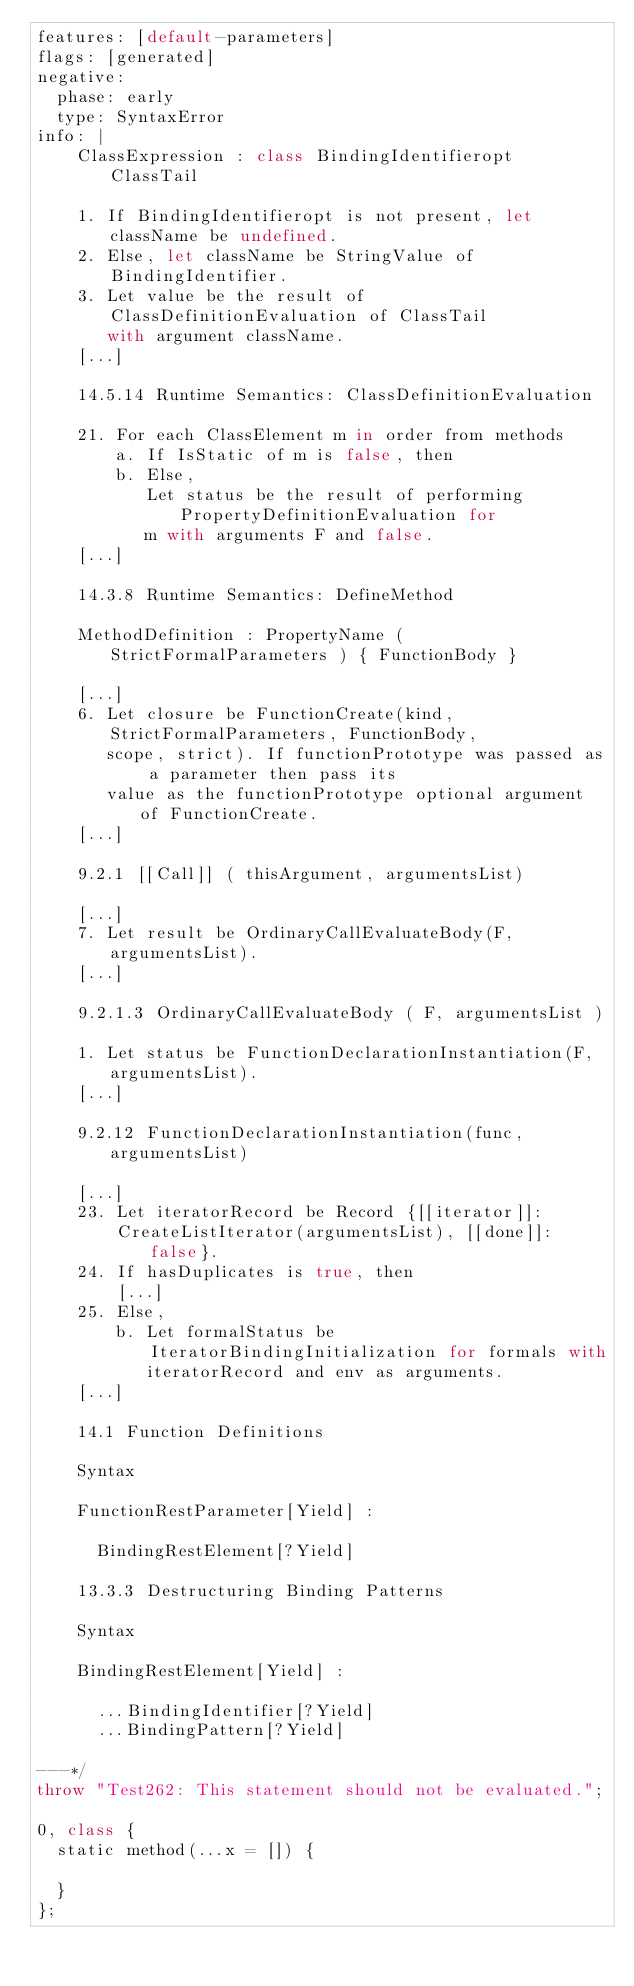Convert code to text. <code><loc_0><loc_0><loc_500><loc_500><_JavaScript_>features: [default-parameters]
flags: [generated]
negative:
  phase: early
  type: SyntaxError
info: |
    ClassExpression : class BindingIdentifieropt ClassTail

    1. If BindingIdentifieropt is not present, let className be undefined.
    2. Else, let className be StringValue of BindingIdentifier.
    3. Let value be the result of ClassDefinitionEvaluation of ClassTail
       with argument className.
    [...]

    14.5.14 Runtime Semantics: ClassDefinitionEvaluation

    21. For each ClassElement m in order from methods
        a. If IsStatic of m is false, then
        b. Else,
           Let status be the result of performing PropertyDefinitionEvaluation for
           m with arguments F and false.
    [...]

    14.3.8 Runtime Semantics: DefineMethod

    MethodDefinition : PropertyName ( StrictFormalParameters ) { FunctionBody }

    [...]
    6. Let closure be FunctionCreate(kind, StrictFormalParameters, FunctionBody,
       scope, strict). If functionPrototype was passed as a parameter then pass its
       value as the functionPrototype optional argument of FunctionCreate.
    [...]

    9.2.1 [[Call]] ( thisArgument, argumentsList)

    [...]
    7. Let result be OrdinaryCallEvaluateBody(F, argumentsList).
    [...]

    9.2.1.3 OrdinaryCallEvaluateBody ( F, argumentsList )

    1. Let status be FunctionDeclarationInstantiation(F, argumentsList).
    [...]

    9.2.12 FunctionDeclarationInstantiation(func, argumentsList)

    [...]
    23. Let iteratorRecord be Record {[[iterator]]:
        CreateListIterator(argumentsList), [[done]]: false}.
    24. If hasDuplicates is true, then
        [...]
    25. Else,
        b. Let formalStatus be IteratorBindingInitialization for formals with
           iteratorRecord and env as arguments.
    [...]

    14.1 Function Definitions

    Syntax

    FunctionRestParameter[Yield] :

      BindingRestElement[?Yield]

    13.3.3 Destructuring Binding Patterns

    Syntax

    BindingRestElement[Yield] :

      ...BindingIdentifier[?Yield]
      ...BindingPattern[?Yield]

---*/
throw "Test262: This statement should not be evaluated.";

0, class {
  static method(...x = []) {
    
  }
};
</code> 